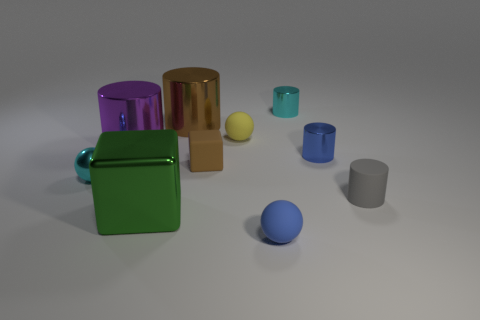The rubber cylinder has what color?
Your response must be concise. Gray. What number of large purple shiny cylinders are in front of the small blue object that is behind the large green metal object?
Offer a very short reply. 0. There is a purple metallic cylinder; is it the same size as the cube that is behind the shiny sphere?
Make the answer very short. No. Is the blue shiny thing the same size as the green block?
Your answer should be compact. No. Is there another brown metallic cylinder of the same size as the brown cylinder?
Your answer should be compact. No. What material is the cyan object behind the yellow ball?
Your answer should be very brief. Metal. There is a block that is made of the same material as the tiny cyan sphere; what color is it?
Provide a short and direct response. Green. How many matte things are brown blocks or big things?
Make the answer very short. 1. There is a yellow matte thing that is the same size as the brown rubber thing; what is its shape?
Provide a succinct answer. Sphere. How many things are either large shiny objects that are behind the large green thing or tiny objects to the left of the blue matte object?
Provide a succinct answer. 5. 